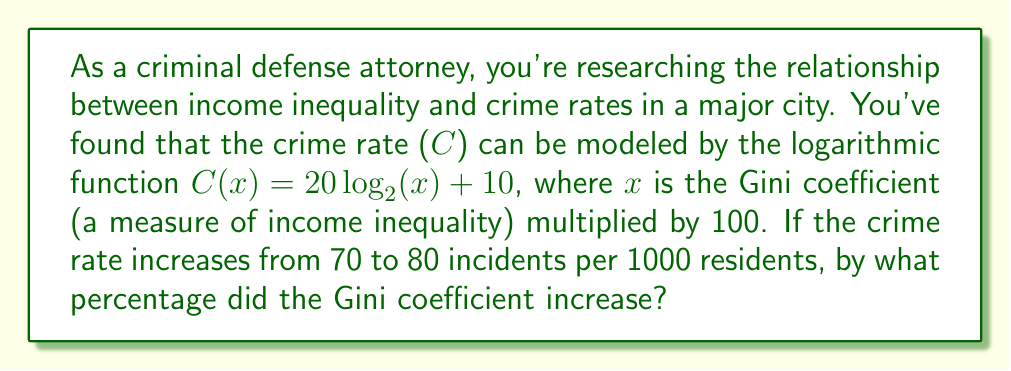Could you help me with this problem? 1) We're given the function $C(x) = 20 \log_2(x) + 10$

2) For the initial crime rate:
   $70 = 20 \log_2(x_1) + 10$
   $60 = 20 \log_2(x_1)$
   $3 = \log_2(x_1)$
   $x_1 = 2^3 = 8$

3) For the final crime rate:
   $80 = 20 \log_2(x_2) + 10$
   $70 = 20 \log_2(x_2)$
   $3.5 = \log_2(x_2)$
   $x_2 = 2^{3.5} \approx 11.31$

4) The percentage increase is:
   $\frac{x_2 - x_1}{x_1} \times 100\% = \frac{11.31 - 8}{8} \times 100\% \approx 41.4\%$

5) Since x represents the Gini coefficient multiplied by 100, the actual Gini coefficient increased by the same percentage.
Answer: 41.4% 